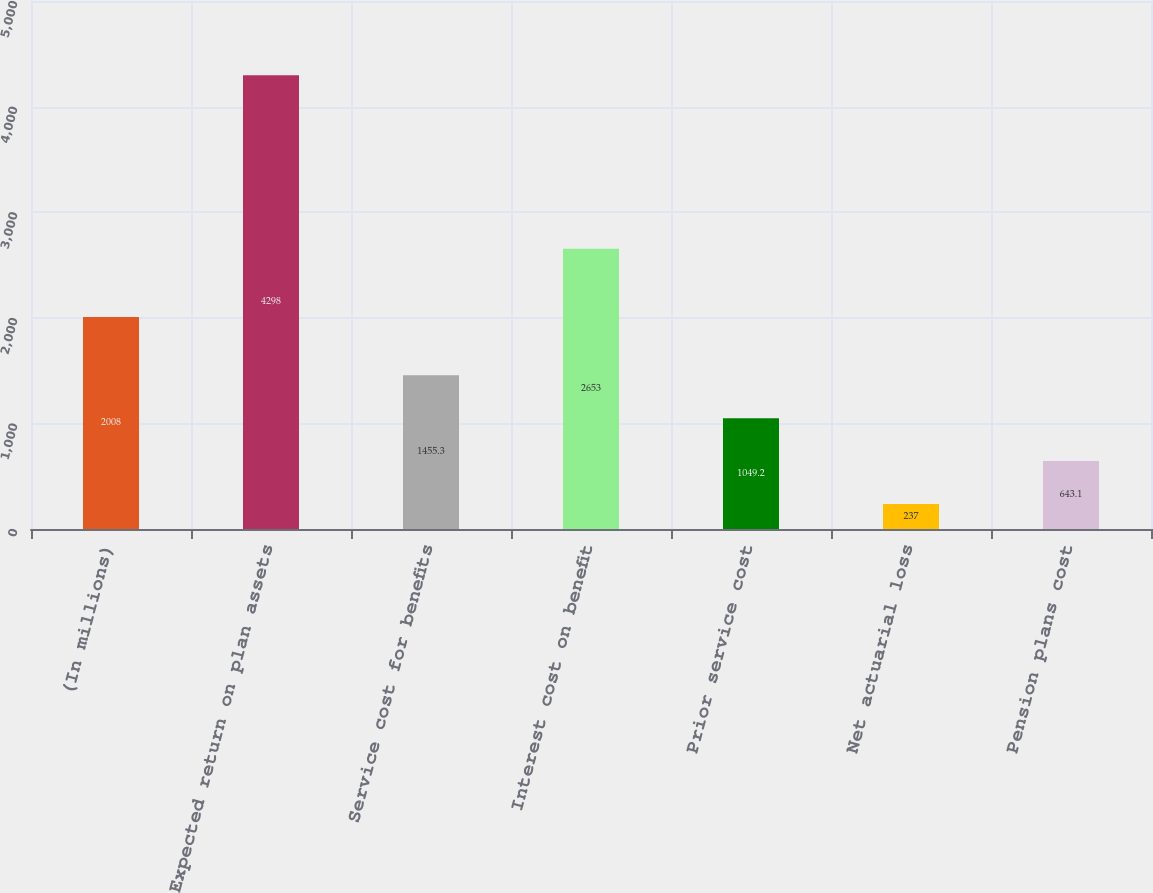Convert chart. <chart><loc_0><loc_0><loc_500><loc_500><bar_chart><fcel>(In millions)<fcel>Expected return on plan assets<fcel>Service cost for benefits<fcel>Interest cost on benefit<fcel>Prior service cost<fcel>Net actuarial loss<fcel>Pension plans cost<nl><fcel>2008<fcel>4298<fcel>1455.3<fcel>2653<fcel>1049.2<fcel>237<fcel>643.1<nl></chart> 